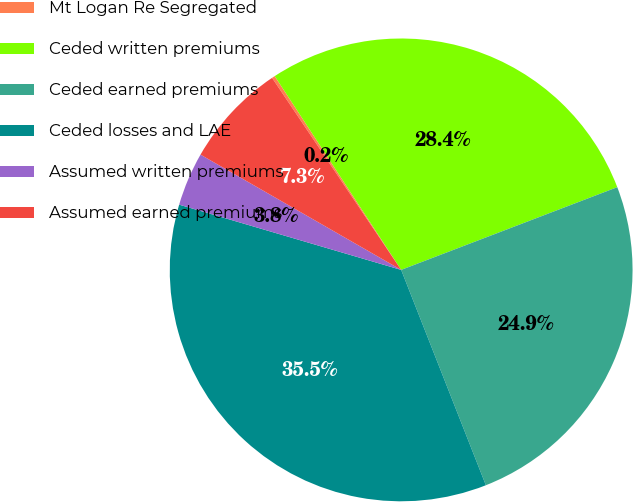<chart> <loc_0><loc_0><loc_500><loc_500><pie_chart><fcel>Mt Logan Re Segregated<fcel>Ceded written premiums<fcel>Ceded earned premiums<fcel>Ceded losses and LAE<fcel>Assumed written premiums<fcel>Assumed earned premiums<nl><fcel>0.22%<fcel>28.38%<fcel>24.85%<fcel>35.51%<fcel>3.75%<fcel>7.28%<nl></chart> 